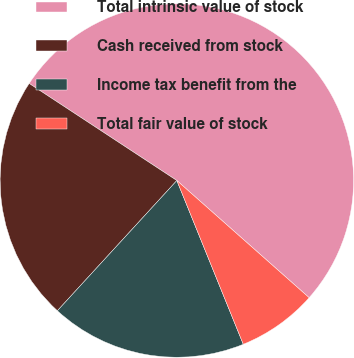<chart> <loc_0><loc_0><loc_500><loc_500><pie_chart><fcel>Total intrinsic value of stock<fcel>Cash received from stock<fcel>Income tax benefit from the<fcel>Total fair value of stock<nl><fcel>52.28%<fcel>22.44%<fcel>17.95%<fcel>7.33%<nl></chart> 